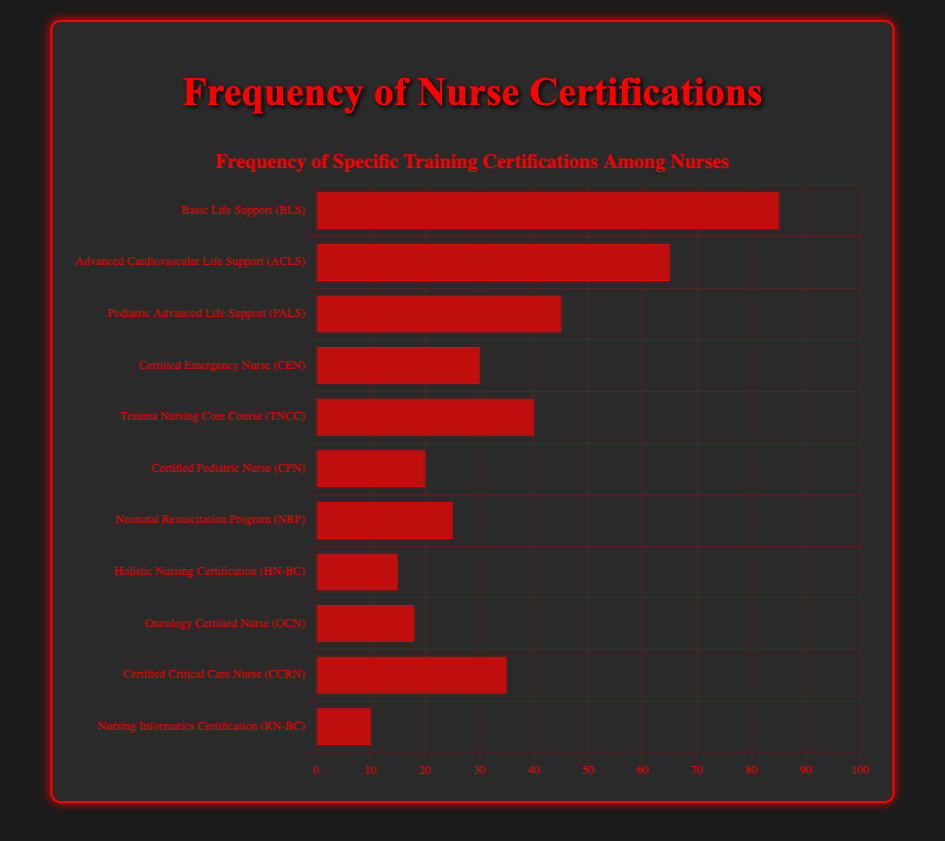Which certification has the highest frequency? The highest frequency is represented by the longest bar. The bar for Basic Life Support (BLS) is the longest, representing a frequency of 85.
Answer: Basic Life Support (BLS) Which certification has the lowest frequency? The lowest frequency is represented by the shortest bar. The bar for Nursing Informatics Certification (RN-BC) is the shortest, representing a frequency of 10.
Answer: Nursing Informatics Certification (RN-BC) How many certifications have a frequency above 50? Count the number of bars with a frequency above the 50 mark. Basic Life Support (BLS) and Advanced Cardiovascular Life Support (ACLS) have frequencies above 50.
Answer: 2 What is the total frequency of certifications related to pediatric care? Sum the frequencies of Pediatric Advanced Life Support (PALS) and Certified Pediatric Nurse (CPN). PALS has a frequency of 45 and CPN has a frequency of 20. The total is 45 + 20 = 65.
Answer: 65 Is the frequency of Holistic Nursing Certification (HN-BC) greater than that of Nursing Informatics Certification (RN-BC)? Compare the heights of the bars for HN-BC and RN-BC. HN-BC has a frequency of 15, which is greater than RN-BC's frequency of 10.
Answer: Yes What is the average frequency of the top three most common certifications? First, identify the top three frequencies: Basic Life Support (BLS) at 85, Advanced Cardiovascular Life Support (ACLS) at 65, and Pediatric Advanced Life Support (PALS) at 45. Calculate the average: (85 + 65 + 45) / 3 = 195 / 3 = 65.
Answer: 65 How does the frequency of Certified Emergency Nurse (CEN) compare to Certified Critical Care Nurse (CCRN)? Compare the heights of the bars for CEN and CCRN. CEN has a frequency of 30 and CCRN has a frequency of 35. CCRN has a slightly higher frequency than CEN.
Answer: CCRN is higher What is the combined frequency of trauma-related certifications? Sum the frequencies of certifications related to trauma: Trauma Nursing Core Course (TNCC) at 40 and Advanced Cardiovascular Life Support (ACLS) at 65. The combined frequency is 40 + 65 = 105.
Answer: 105 Are there more certifications with frequencies above or below 20? Count the number of certifications with frequencies above 20 (7 certifications: BLS, ACLS, PALS, CEN, TNCC, NRP, CCRN) and those below or equal to 20 (4 certifications: CPN, HN-BC, OCN, RN-BC). There are more certifications with frequencies above 20.
Answer: Above 